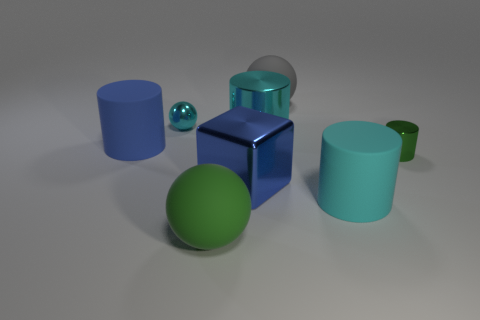Add 2 small green objects. How many objects exist? 10 Subtract all green cylinders. How many cylinders are left? 3 Subtract all purple rubber cylinders. Subtract all blue metal things. How many objects are left? 7 Add 3 blue cylinders. How many blue cylinders are left? 4 Add 3 big rubber spheres. How many big rubber spheres exist? 5 Subtract all cyan cylinders. How many cylinders are left? 2 Subtract 0 cyan cubes. How many objects are left? 8 Subtract all cubes. How many objects are left? 7 Subtract 2 cylinders. How many cylinders are left? 2 Subtract all brown blocks. Subtract all purple cylinders. How many blocks are left? 1 